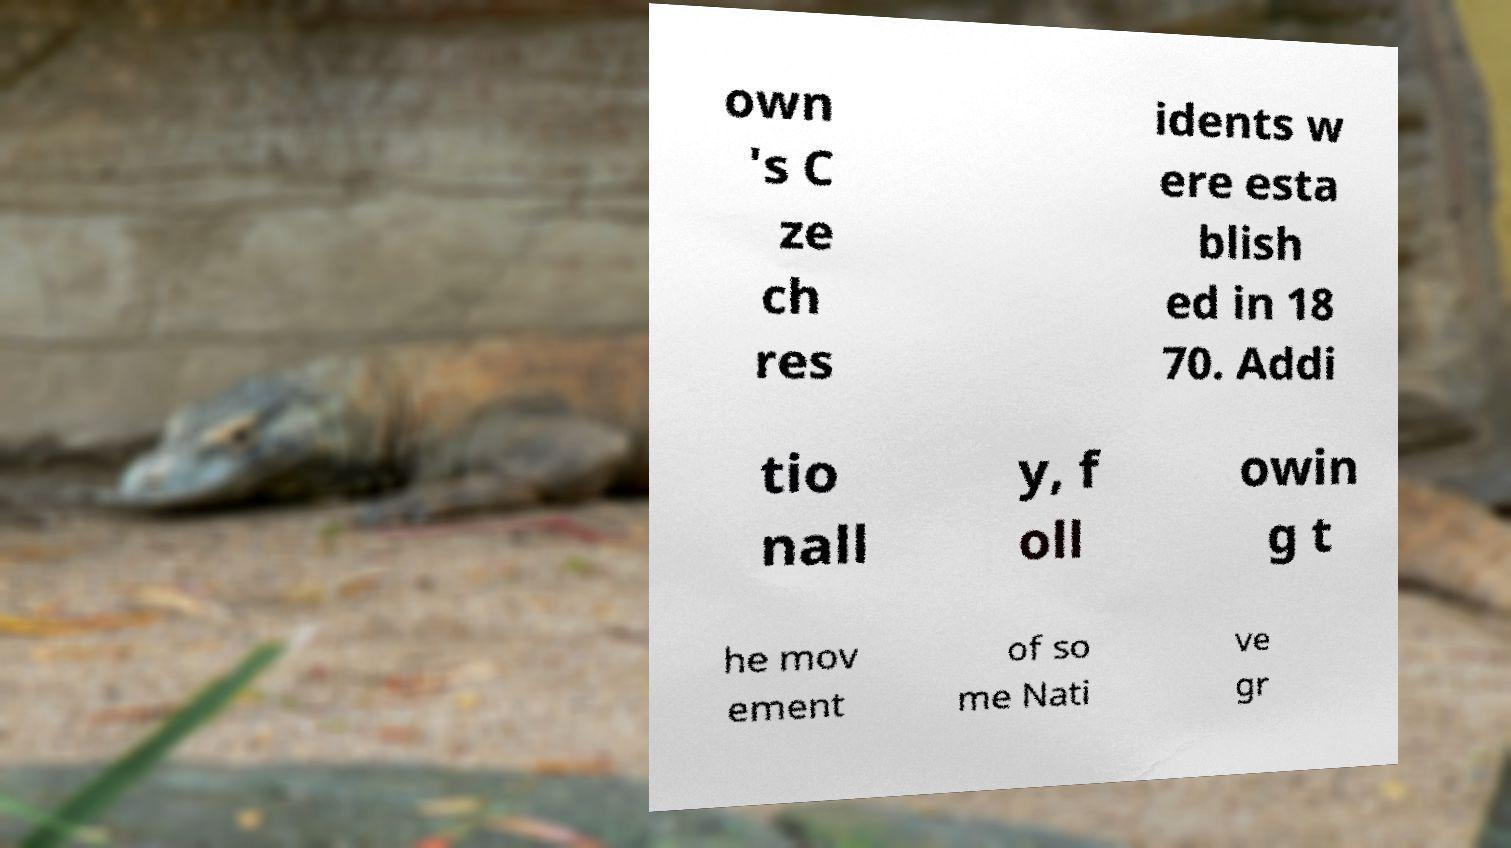Can you read and provide the text displayed in the image?This photo seems to have some interesting text. Can you extract and type it out for me? own 's C ze ch res idents w ere esta blish ed in 18 70. Addi tio nall y, f oll owin g t he mov ement of so me Nati ve gr 